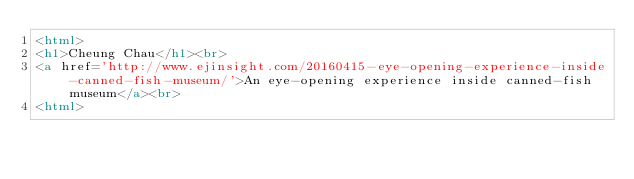<code> <loc_0><loc_0><loc_500><loc_500><_HTML_><html>
<h1>Cheung Chau</h1><br>
<a href='http://www.ejinsight.com/20160415-eye-opening-experience-inside-canned-fish-museum/'>An eye-opening experience inside canned-fish museum</a><br>
<html></code> 